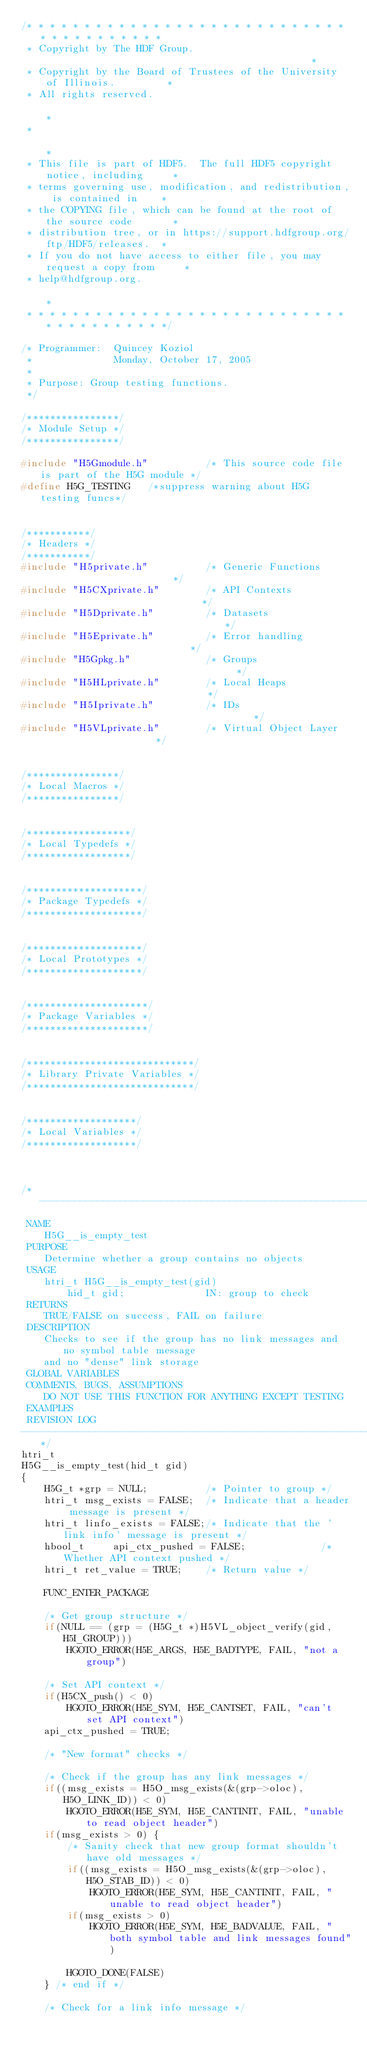<code> <loc_0><loc_0><loc_500><loc_500><_C_>/* * * * * * * * * * * * * * * * * * * * * * * * * * * * * * * * * * * * * * *
 * Copyright by The HDF Group.                                               *
 * Copyright by the Board of Trustees of the University of Illinois.         *
 * All rights reserved.                                                      *
 *                                                                           *
 * This file is part of HDF5.  The full HDF5 copyright notice, including     *
 * terms governing use, modification, and redistribution, is contained in    *
 * the COPYING file, which can be found at the root of the source code       *
 * distribution tree, or in https://support.hdfgroup.org/ftp/HDF5/releases.  *
 * If you do not have access to either file, you may request a copy from     *
 * help@hdfgroup.org.                                                        *
 * * * * * * * * * * * * * * * * * * * * * * * * * * * * * * * * * * * * * * */

/* Programmer:  Quincey Koziol
 *              Monday, October 17, 2005
 *
 * Purpose:	Group testing functions.
 */

/****************/
/* Module Setup */
/****************/

#include "H5Gmodule.h"          /* This source code file is part of the H5G module */
#define H5G_TESTING		/*suppress warning about H5G testing funcs*/


/***********/
/* Headers */
/***********/
#include "H5private.h"          /* Generic Functions                        */
#include "H5CXprivate.h"        /* API Contexts                             */
#include "H5Dprivate.h"         /* Datasets                                 */
#include "H5Eprivate.h"         /* Error handling                           */
#include "H5Gpkg.h"             /* Groups                                   */
#include "H5HLprivate.h"        /* Local Heaps                              */
#include "H5Iprivate.h"         /* IDs                                      */
#include "H5VLprivate.h"        /* Virtual Object Layer                     */


/****************/
/* Local Macros */
/****************/


/******************/
/* Local Typedefs */
/******************/


/********************/
/* Package Typedefs */
/********************/


/********************/
/* Local Prototypes */
/********************/


/*********************/
/* Package Variables */
/*********************/


/*****************************/
/* Library Private Variables */
/*****************************/


/*******************/
/* Local Variables */
/*******************/


/*--------------------------------------------------------------------------
 NAME
    H5G__is_empty_test
 PURPOSE
    Determine whether a group contains no objects
 USAGE
    htri_t H5G__is_empty_test(gid)
        hid_t gid;              IN: group to check
 RETURNS
    TRUE/FALSE on success, FAIL on failure
 DESCRIPTION
    Checks to see if the group has no link messages and no symbol table message
    and no "dense" link storage
 GLOBAL VARIABLES
 COMMENTS, BUGS, ASSUMPTIONS
    DO NOT USE THIS FUNCTION FOR ANYTHING EXCEPT TESTING
 EXAMPLES
 REVISION LOG
--------------------------------------------------------------------------*/
htri_t
H5G__is_empty_test(hid_t gid)
{
    H5G_t *grp = NULL;          /* Pointer to group */
    htri_t msg_exists = FALSE;  /* Indicate that a header message is present */
    htri_t linfo_exists = FALSE;/* Indicate that the 'link info' message is present */
    hbool_t     api_ctx_pushed = FALSE;             /* Whether API context pushed */
    htri_t ret_value = TRUE;    /* Return value */

    FUNC_ENTER_PACKAGE

    /* Get group structure */
    if(NULL == (grp = (H5G_t *)H5VL_object_verify(gid, H5I_GROUP)))
        HGOTO_ERROR(H5E_ARGS, H5E_BADTYPE, FAIL, "not a group")

    /* Set API context */
    if(H5CX_push() < 0)
        HGOTO_ERROR(H5E_SYM, H5E_CANTSET, FAIL, "can't set API context")
    api_ctx_pushed = TRUE;

    /* "New format" checks */

    /* Check if the group has any link messages */
    if((msg_exists = H5O_msg_exists(&(grp->oloc), H5O_LINK_ID)) < 0)
        HGOTO_ERROR(H5E_SYM, H5E_CANTINIT, FAIL, "unable to read object header")
    if(msg_exists > 0) {
        /* Sanity check that new group format shouldn't have old messages */
        if((msg_exists = H5O_msg_exists(&(grp->oloc), H5O_STAB_ID)) < 0)
            HGOTO_ERROR(H5E_SYM, H5E_CANTINIT, FAIL, "unable to read object header")
        if(msg_exists > 0)
            HGOTO_ERROR(H5E_SYM, H5E_BADVALUE, FAIL, "both symbol table and link messages found")

        HGOTO_DONE(FALSE)
    } /* end if */

    /* Check for a link info message */</code> 